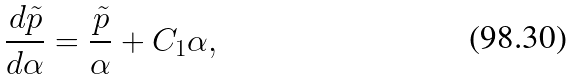<formula> <loc_0><loc_0><loc_500><loc_500>\frac { d \tilde { p } } { d \alpha } = \frac { \tilde { p } } { \alpha } + C _ { 1 } \alpha ,</formula> 